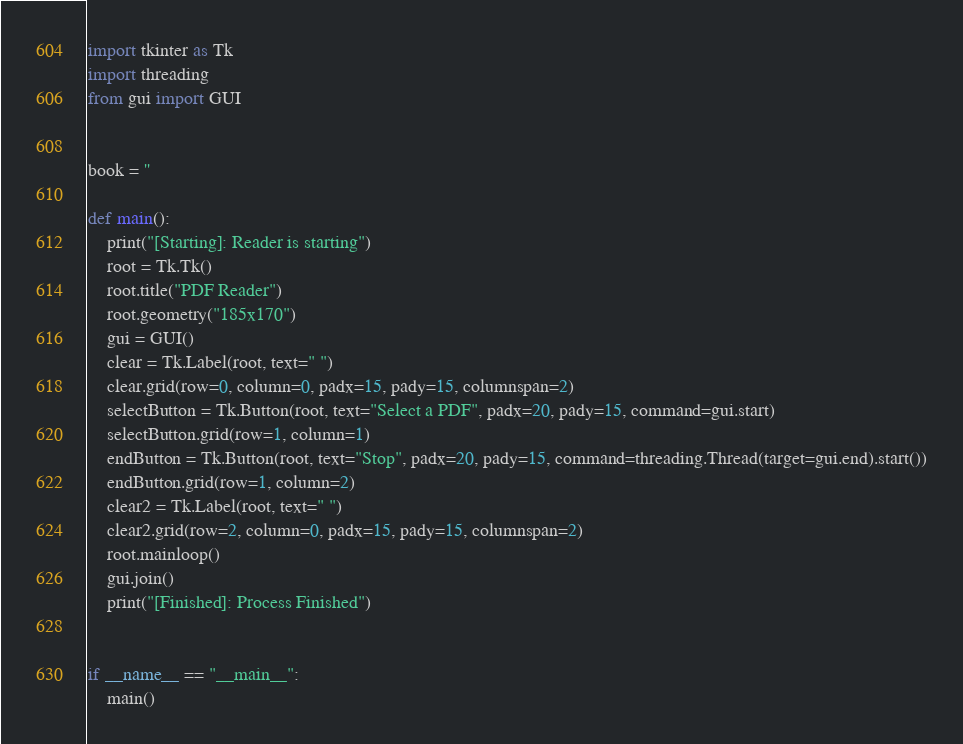<code> <loc_0><loc_0><loc_500><loc_500><_Python_>import tkinter as Tk
import threading
from gui import GUI


book = ''

def main():
    print("[Starting]: Reader is starting")
    root = Tk.Tk()
    root.title("PDF Reader")
    root.geometry("185x170")
    gui = GUI()
    clear = Tk.Label(root, text=" ")
    clear.grid(row=0, column=0, padx=15, pady=15, columnspan=2)
    selectButton = Tk.Button(root, text="Select a PDF", padx=20, pady=15, command=gui.start)
    selectButton.grid(row=1, column=1)
    endButton = Tk.Button(root, text="Stop", padx=20, pady=15, command=threading.Thread(target=gui.end).start())
    endButton.grid(row=1, column=2)
    clear2 = Tk.Label(root, text=" ")
    clear2.grid(row=2, column=0, padx=15, pady=15, columnspan=2)
    root.mainloop()
    gui.join()
    print("[Finished]: Process Finished")


if __name__ == "__main__":
    main()

</code> 